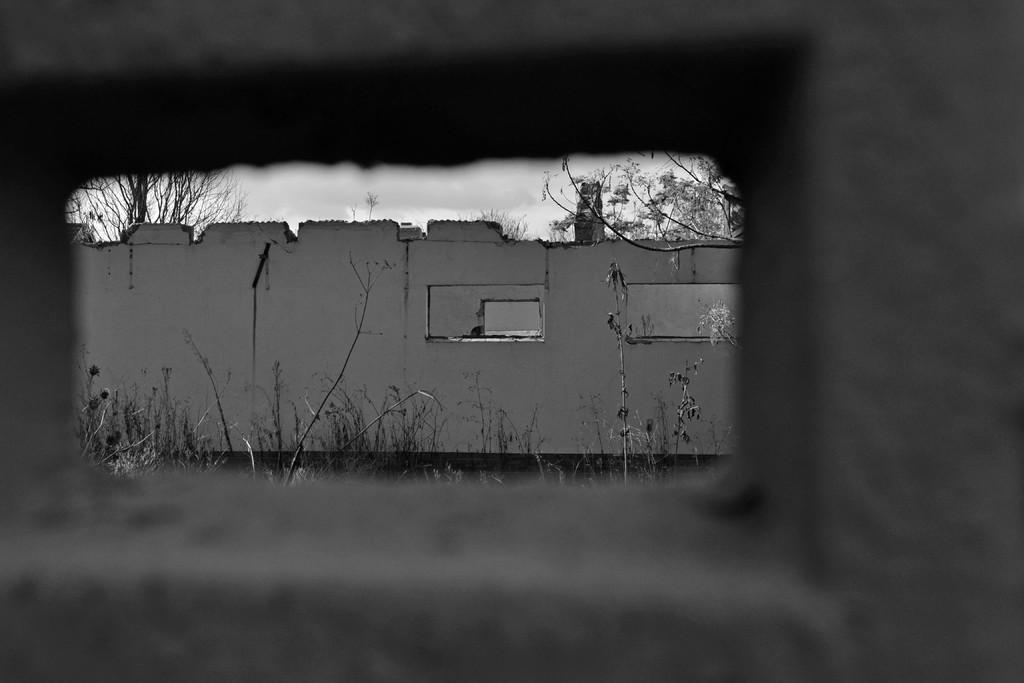What is the color scheme of the image? The image is black and white. What type of structure can be seen in the image? There is a wall in the image. What type of vegetation is present in the image? There are plants and trees in the image. What part of the natural environment is visible in the image? The sky is visible in the image. Can you see the crook trying to steal the island in the image? There is no crook or island present in the image. How many legs are visible in the image? There are no legs visible in the image. 